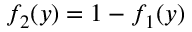<formula> <loc_0><loc_0><loc_500><loc_500>f _ { 2 } ( y ) = 1 - f _ { 1 } ( y )</formula> 